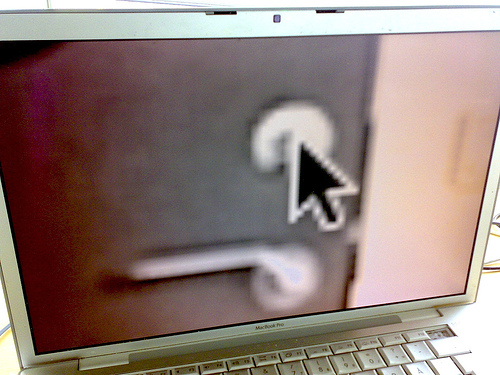<image>
Is the cursor on the door? Yes. Looking at the image, I can see the cursor is positioned on top of the door, with the door providing support. 